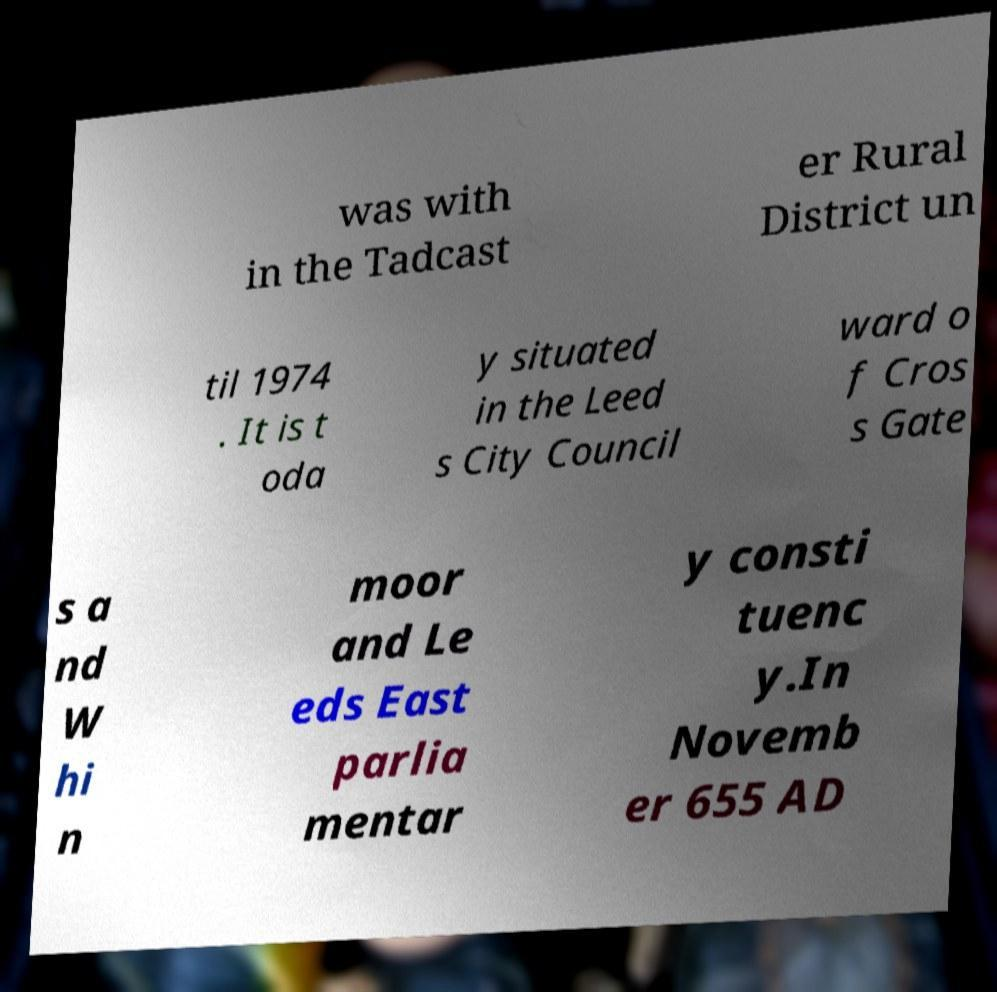Could you extract and type out the text from this image? was with in the Tadcast er Rural District un til 1974 . It is t oda y situated in the Leed s City Council ward o f Cros s Gate s a nd W hi n moor and Le eds East parlia mentar y consti tuenc y.In Novemb er 655 AD 